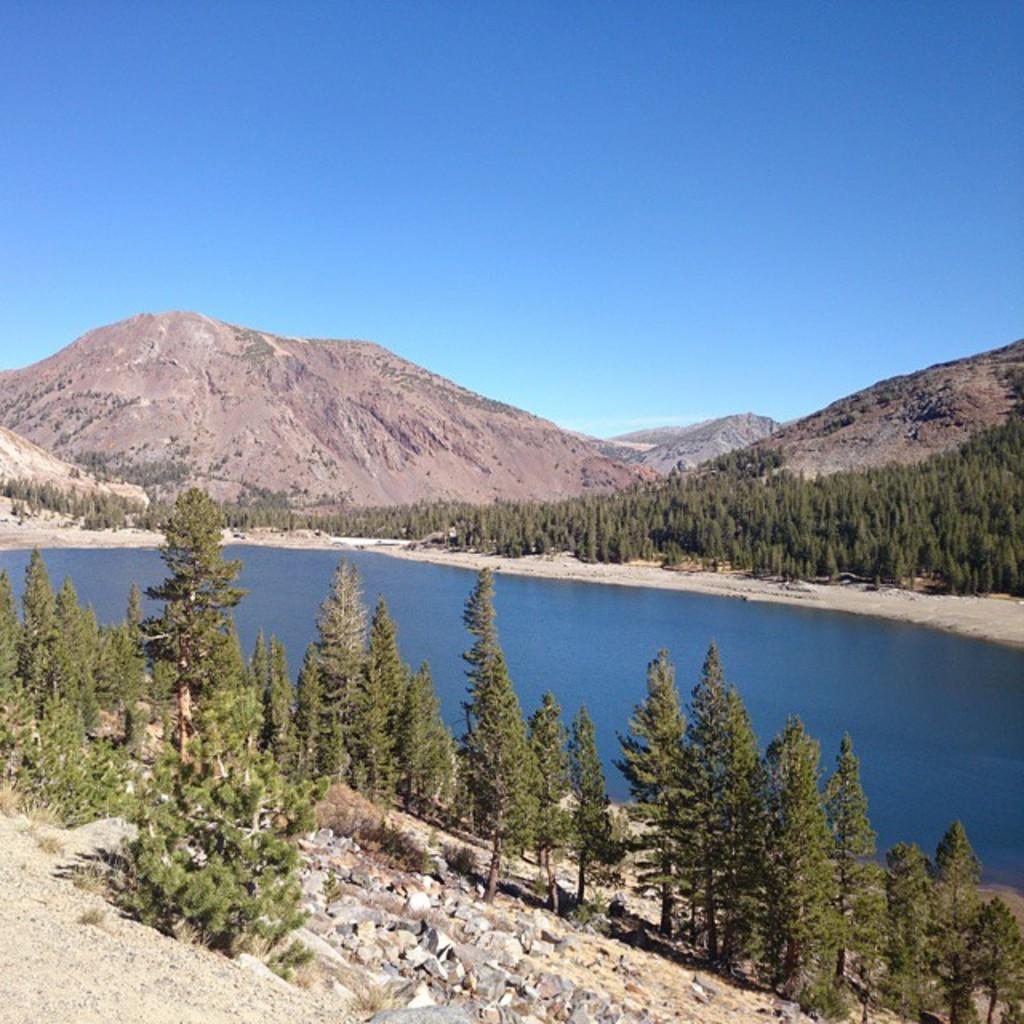What type of natural environment is depicted in the image? The image features trees, water, mountains, and rocks, which are all elements of a natural environment. Can you describe the water in the image? The water is visible in the image, but its specific characteristics are not mentioned in the facts. What else can be seen in the sky in the image? The sky is visible in the image, but no additional details are provided in the facts. How many lizards are sitting on the desk in the image? There is no desk or lizards present in the image. 